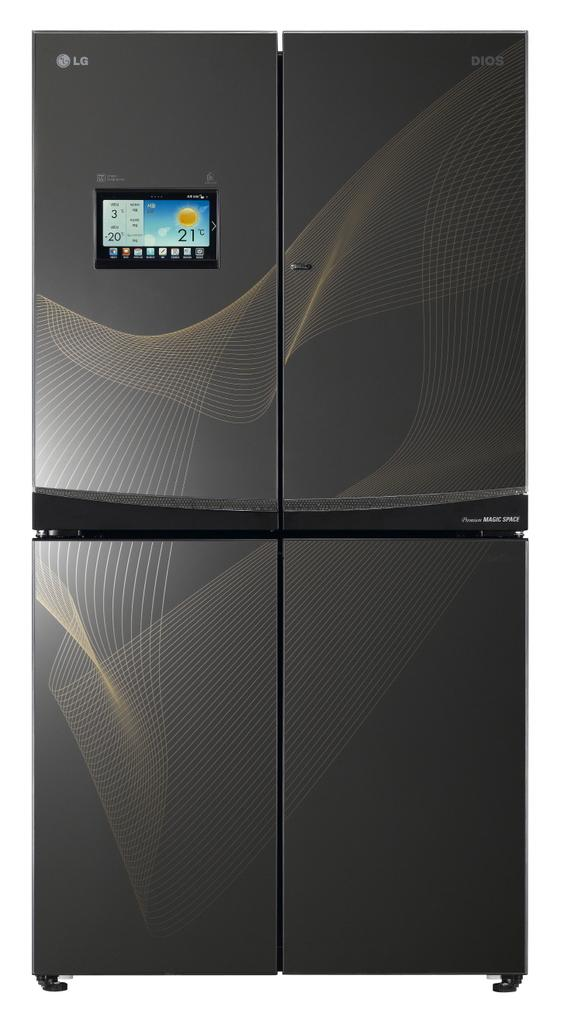<image>
Provide a brief description of the given image. A black LG refrigerator that shows 21 degrees Celsius outside. 